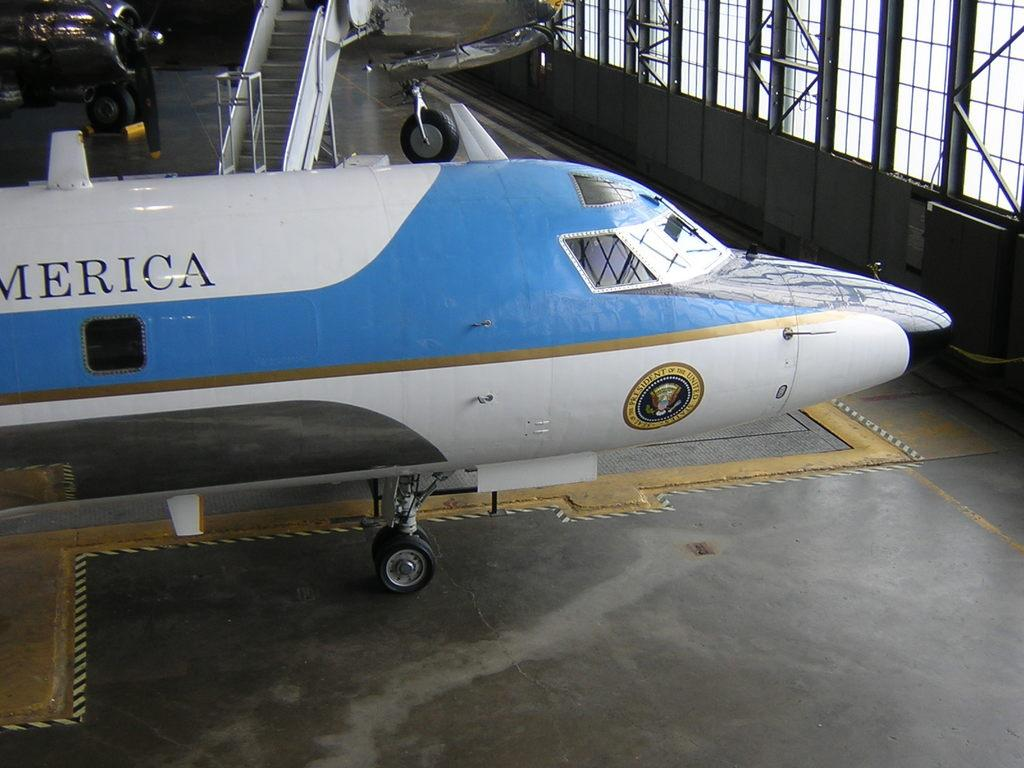<image>
Provide a brief description of the given image. A United States of America airplane inside or a hanger with a round seal on the side that says President  of the United States. 